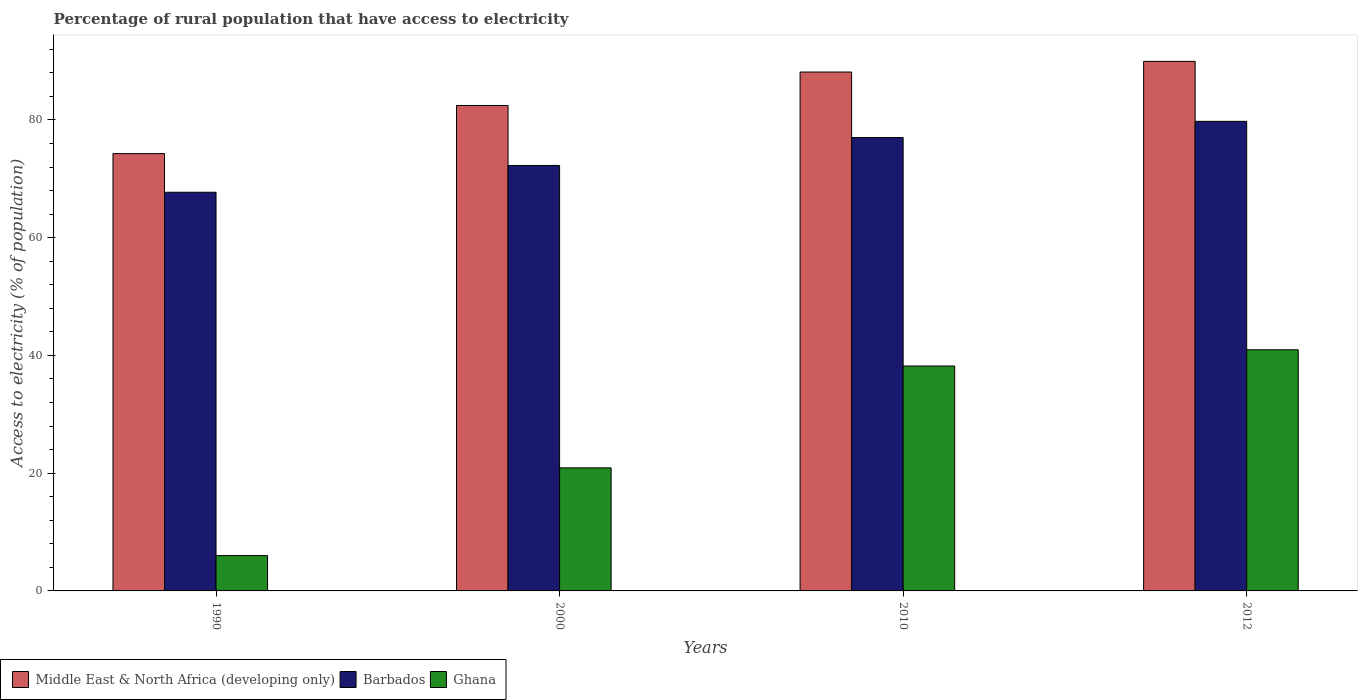How many different coloured bars are there?
Offer a terse response. 3. How many groups of bars are there?
Your answer should be very brief. 4. Are the number of bars per tick equal to the number of legend labels?
Give a very brief answer. Yes. How many bars are there on the 4th tick from the left?
Offer a terse response. 3. What is the label of the 1st group of bars from the left?
Keep it short and to the point. 1990. In how many cases, is the number of bars for a given year not equal to the number of legend labels?
Ensure brevity in your answer.  0. What is the percentage of rural population that have access to electricity in Ghana in 2012?
Your answer should be very brief. 40.95. Across all years, what is the maximum percentage of rural population that have access to electricity in Barbados?
Provide a succinct answer. 79.75. In which year was the percentage of rural population that have access to electricity in Ghana maximum?
Your answer should be very brief. 2012. In which year was the percentage of rural population that have access to electricity in Barbados minimum?
Make the answer very short. 1990. What is the total percentage of rural population that have access to electricity in Ghana in the graph?
Give a very brief answer. 106.05. What is the difference between the percentage of rural population that have access to electricity in Middle East & North Africa (developing only) in 1990 and that in 2000?
Your response must be concise. -8.17. What is the difference between the percentage of rural population that have access to electricity in Middle East & North Africa (developing only) in 2010 and the percentage of rural population that have access to electricity in Barbados in 1990?
Provide a succinct answer. 20.42. What is the average percentage of rural population that have access to electricity in Middle East & North Africa (developing only) per year?
Make the answer very short. 83.7. In the year 1990, what is the difference between the percentage of rural population that have access to electricity in Middle East & North Africa (developing only) and percentage of rural population that have access to electricity in Barbados?
Give a very brief answer. 6.57. In how many years, is the percentage of rural population that have access to electricity in Barbados greater than 64 %?
Ensure brevity in your answer.  4. What is the ratio of the percentage of rural population that have access to electricity in Ghana in 1990 to that in 2012?
Your answer should be very brief. 0.15. Is the percentage of rural population that have access to electricity in Ghana in 2000 less than that in 2012?
Offer a terse response. Yes. Is the difference between the percentage of rural population that have access to electricity in Middle East & North Africa (developing only) in 2000 and 2012 greater than the difference between the percentage of rural population that have access to electricity in Barbados in 2000 and 2012?
Provide a succinct answer. No. What is the difference between the highest and the second highest percentage of rural population that have access to electricity in Ghana?
Your answer should be very brief. 2.75. What is the difference between the highest and the lowest percentage of rural population that have access to electricity in Ghana?
Your response must be concise. 34.95. In how many years, is the percentage of rural population that have access to electricity in Ghana greater than the average percentage of rural population that have access to electricity in Ghana taken over all years?
Offer a very short reply. 2. What does the 3rd bar from the left in 1990 represents?
Your answer should be compact. Ghana. What does the 1st bar from the right in 2000 represents?
Provide a short and direct response. Ghana. How many bars are there?
Give a very brief answer. 12. Are the values on the major ticks of Y-axis written in scientific E-notation?
Your answer should be very brief. No. How are the legend labels stacked?
Your answer should be very brief. Horizontal. What is the title of the graph?
Your answer should be compact. Percentage of rural population that have access to electricity. What is the label or title of the X-axis?
Provide a short and direct response. Years. What is the label or title of the Y-axis?
Your answer should be very brief. Access to electricity (% of population). What is the Access to electricity (% of population) of Middle East & North Africa (developing only) in 1990?
Ensure brevity in your answer.  74.28. What is the Access to electricity (% of population) in Barbados in 1990?
Offer a very short reply. 67.71. What is the Access to electricity (% of population) in Ghana in 1990?
Your answer should be very brief. 6. What is the Access to electricity (% of population) in Middle East & North Africa (developing only) in 2000?
Ensure brevity in your answer.  82.45. What is the Access to electricity (% of population) in Barbados in 2000?
Your answer should be compact. 72.27. What is the Access to electricity (% of population) of Ghana in 2000?
Offer a very short reply. 20.9. What is the Access to electricity (% of population) in Middle East & North Africa (developing only) in 2010?
Your answer should be compact. 88.13. What is the Access to electricity (% of population) in Ghana in 2010?
Provide a succinct answer. 38.2. What is the Access to electricity (% of population) in Middle East & North Africa (developing only) in 2012?
Ensure brevity in your answer.  89.94. What is the Access to electricity (% of population) in Barbados in 2012?
Give a very brief answer. 79.75. What is the Access to electricity (% of population) of Ghana in 2012?
Ensure brevity in your answer.  40.95. Across all years, what is the maximum Access to electricity (% of population) in Middle East & North Africa (developing only)?
Make the answer very short. 89.94. Across all years, what is the maximum Access to electricity (% of population) in Barbados?
Make the answer very short. 79.75. Across all years, what is the maximum Access to electricity (% of population) in Ghana?
Offer a very short reply. 40.95. Across all years, what is the minimum Access to electricity (% of population) of Middle East & North Africa (developing only)?
Your response must be concise. 74.28. Across all years, what is the minimum Access to electricity (% of population) of Barbados?
Keep it short and to the point. 67.71. What is the total Access to electricity (% of population) of Middle East & North Africa (developing only) in the graph?
Keep it short and to the point. 334.8. What is the total Access to electricity (% of population) of Barbados in the graph?
Provide a succinct answer. 296.73. What is the total Access to electricity (% of population) of Ghana in the graph?
Your response must be concise. 106.05. What is the difference between the Access to electricity (% of population) in Middle East & North Africa (developing only) in 1990 and that in 2000?
Offer a very short reply. -8.17. What is the difference between the Access to electricity (% of population) in Barbados in 1990 and that in 2000?
Keep it short and to the point. -4.55. What is the difference between the Access to electricity (% of population) in Ghana in 1990 and that in 2000?
Your answer should be compact. -14.9. What is the difference between the Access to electricity (% of population) in Middle East & North Africa (developing only) in 1990 and that in 2010?
Provide a succinct answer. -13.86. What is the difference between the Access to electricity (% of population) in Barbados in 1990 and that in 2010?
Provide a short and direct response. -9.29. What is the difference between the Access to electricity (% of population) of Ghana in 1990 and that in 2010?
Your response must be concise. -32.2. What is the difference between the Access to electricity (% of population) of Middle East & North Africa (developing only) in 1990 and that in 2012?
Give a very brief answer. -15.67. What is the difference between the Access to electricity (% of population) in Barbados in 1990 and that in 2012?
Your answer should be compact. -12.04. What is the difference between the Access to electricity (% of population) in Ghana in 1990 and that in 2012?
Keep it short and to the point. -34.95. What is the difference between the Access to electricity (% of population) in Middle East & North Africa (developing only) in 2000 and that in 2010?
Give a very brief answer. -5.68. What is the difference between the Access to electricity (% of population) of Barbados in 2000 and that in 2010?
Give a very brief answer. -4.74. What is the difference between the Access to electricity (% of population) of Ghana in 2000 and that in 2010?
Provide a succinct answer. -17.3. What is the difference between the Access to electricity (% of population) in Middle East & North Africa (developing only) in 2000 and that in 2012?
Make the answer very short. -7.5. What is the difference between the Access to electricity (% of population) of Barbados in 2000 and that in 2012?
Give a very brief answer. -7.49. What is the difference between the Access to electricity (% of population) in Ghana in 2000 and that in 2012?
Offer a terse response. -20.05. What is the difference between the Access to electricity (% of population) in Middle East & North Africa (developing only) in 2010 and that in 2012?
Provide a short and direct response. -1.81. What is the difference between the Access to electricity (% of population) of Barbados in 2010 and that in 2012?
Provide a succinct answer. -2.75. What is the difference between the Access to electricity (% of population) in Ghana in 2010 and that in 2012?
Make the answer very short. -2.75. What is the difference between the Access to electricity (% of population) in Middle East & North Africa (developing only) in 1990 and the Access to electricity (% of population) in Barbados in 2000?
Give a very brief answer. 2.01. What is the difference between the Access to electricity (% of population) in Middle East & North Africa (developing only) in 1990 and the Access to electricity (% of population) in Ghana in 2000?
Offer a very short reply. 53.38. What is the difference between the Access to electricity (% of population) of Barbados in 1990 and the Access to electricity (% of population) of Ghana in 2000?
Provide a succinct answer. 46.81. What is the difference between the Access to electricity (% of population) of Middle East & North Africa (developing only) in 1990 and the Access to electricity (% of population) of Barbados in 2010?
Your answer should be compact. -2.72. What is the difference between the Access to electricity (% of population) of Middle East & North Africa (developing only) in 1990 and the Access to electricity (% of population) of Ghana in 2010?
Make the answer very short. 36.08. What is the difference between the Access to electricity (% of population) in Barbados in 1990 and the Access to electricity (% of population) in Ghana in 2010?
Keep it short and to the point. 29.51. What is the difference between the Access to electricity (% of population) of Middle East & North Africa (developing only) in 1990 and the Access to electricity (% of population) of Barbados in 2012?
Your response must be concise. -5.48. What is the difference between the Access to electricity (% of population) in Middle East & North Africa (developing only) in 1990 and the Access to electricity (% of population) in Ghana in 2012?
Your answer should be compact. 33.32. What is the difference between the Access to electricity (% of population) in Barbados in 1990 and the Access to electricity (% of population) in Ghana in 2012?
Your answer should be very brief. 26.76. What is the difference between the Access to electricity (% of population) in Middle East & North Africa (developing only) in 2000 and the Access to electricity (% of population) in Barbados in 2010?
Make the answer very short. 5.45. What is the difference between the Access to electricity (% of population) of Middle East & North Africa (developing only) in 2000 and the Access to electricity (% of population) of Ghana in 2010?
Make the answer very short. 44.25. What is the difference between the Access to electricity (% of population) of Barbados in 2000 and the Access to electricity (% of population) of Ghana in 2010?
Make the answer very short. 34.06. What is the difference between the Access to electricity (% of population) in Middle East & North Africa (developing only) in 2000 and the Access to electricity (% of population) in Barbados in 2012?
Provide a succinct answer. 2.69. What is the difference between the Access to electricity (% of population) of Middle East & North Africa (developing only) in 2000 and the Access to electricity (% of population) of Ghana in 2012?
Provide a succinct answer. 41.49. What is the difference between the Access to electricity (% of population) in Barbados in 2000 and the Access to electricity (% of population) in Ghana in 2012?
Your answer should be very brief. 31.31. What is the difference between the Access to electricity (% of population) of Middle East & North Africa (developing only) in 2010 and the Access to electricity (% of population) of Barbados in 2012?
Your response must be concise. 8.38. What is the difference between the Access to electricity (% of population) of Middle East & North Africa (developing only) in 2010 and the Access to electricity (% of population) of Ghana in 2012?
Keep it short and to the point. 47.18. What is the difference between the Access to electricity (% of population) of Barbados in 2010 and the Access to electricity (% of population) of Ghana in 2012?
Make the answer very short. 36.05. What is the average Access to electricity (% of population) in Middle East & North Africa (developing only) per year?
Offer a terse response. 83.7. What is the average Access to electricity (% of population) in Barbados per year?
Ensure brevity in your answer.  74.18. What is the average Access to electricity (% of population) of Ghana per year?
Provide a short and direct response. 26.51. In the year 1990, what is the difference between the Access to electricity (% of population) of Middle East & North Africa (developing only) and Access to electricity (% of population) of Barbados?
Offer a very short reply. 6.57. In the year 1990, what is the difference between the Access to electricity (% of population) of Middle East & North Africa (developing only) and Access to electricity (% of population) of Ghana?
Provide a succinct answer. 68.28. In the year 1990, what is the difference between the Access to electricity (% of population) of Barbados and Access to electricity (% of population) of Ghana?
Keep it short and to the point. 61.71. In the year 2000, what is the difference between the Access to electricity (% of population) of Middle East & North Africa (developing only) and Access to electricity (% of population) of Barbados?
Keep it short and to the point. 10.18. In the year 2000, what is the difference between the Access to electricity (% of population) of Middle East & North Africa (developing only) and Access to electricity (% of population) of Ghana?
Ensure brevity in your answer.  61.55. In the year 2000, what is the difference between the Access to electricity (% of population) of Barbados and Access to electricity (% of population) of Ghana?
Provide a succinct answer. 51.37. In the year 2010, what is the difference between the Access to electricity (% of population) in Middle East & North Africa (developing only) and Access to electricity (% of population) in Barbados?
Offer a terse response. 11.13. In the year 2010, what is the difference between the Access to electricity (% of population) in Middle East & North Africa (developing only) and Access to electricity (% of population) in Ghana?
Make the answer very short. 49.93. In the year 2010, what is the difference between the Access to electricity (% of population) of Barbados and Access to electricity (% of population) of Ghana?
Make the answer very short. 38.8. In the year 2012, what is the difference between the Access to electricity (% of population) in Middle East & North Africa (developing only) and Access to electricity (% of population) in Barbados?
Provide a succinct answer. 10.19. In the year 2012, what is the difference between the Access to electricity (% of population) of Middle East & North Africa (developing only) and Access to electricity (% of population) of Ghana?
Provide a short and direct response. 48.99. In the year 2012, what is the difference between the Access to electricity (% of population) of Barbados and Access to electricity (% of population) of Ghana?
Your response must be concise. 38.8. What is the ratio of the Access to electricity (% of population) in Middle East & North Africa (developing only) in 1990 to that in 2000?
Give a very brief answer. 0.9. What is the ratio of the Access to electricity (% of population) of Barbados in 1990 to that in 2000?
Ensure brevity in your answer.  0.94. What is the ratio of the Access to electricity (% of population) in Ghana in 1990 to that in 2000?
Give a very brief answer. 0.29. What is the ratio of the Access to electricity (% of population) in Middle East & North Africa (developing only) in 1990 to that in 2010?
Your answer should be compact. 0.84. What is the ratio of the Access to electricity (% of population) of Barbados in 1990 to that in 2010?
Ensure brevity in your answer.  0.88. What is the ratio of the Access to electricity (% of population) in Ghana in 1990 to that in 2010?
Your answer should be compact. 0.16. What is the ratio of the Access to electricity (% of population) in Middle East & North Africa (developing only) in 1990 to that in 2012?
Ensure brevity in your answer.  0.83. What is the ratio of the Access to electricity (% of population) in Barbados in 1990 to that in 2012?
Keep it short and to the point. 0.85. What is the ratio of the Access to electricity (% of population) of Ghana in 1990 to that in 2012?
Ensure brevity in your answer.  0.15. What is the ratio of the Access to electricity (% of population) in Middle East & North Africa (developing only) in 2000 to that in 2010?
Make the answer very short. 0.94. What is the ratio of the Access to electricity (% of population) of Barbados in 2000 to that in 2010?
Offer a very short reply. 0.94. What is the ratio of the Access to electricity (% of population) in Ghana in 2000 to that in 2010?
Give a very brief answer. 0.55. What is the ratio of the Access to electricity (% of population) in Barbados in 2000 to that in 2012?
Give a very brief answer. 0.91. What is the ratio of the Access to electricity (% of population) of Ghana in 2000 to that in 2012?
Keep it short and to the point. 0.51. What is the ratio of the Access to electricity (% of population) in Middle East & North Africa (developing only) in 2010 to that in 2012?
Provide a short and direct response. 0.98. What is the ratio of the Access to electricity (% of population) in Barbados in 2010 to that in 2012?
Offer a terse response. 0.97. What is the ratio of the Access to electricity (% of population) of Ghana in 2010 to that in 2012?
Keep it short and to the point. 0.93. What is the difference between the highest and the second highest Access to electricity (% of population) in Middle East & North Africa (developing only)?
Your response must be concise. 1.81. What is the difference between the highest and the second highest Access to electricity (% of population) of Barbados?
Keep it short and to the point. 2.75. What is the difference between the highest and the second highest Access to electricity (% of population) in Ghana?
Ensure brevity in your answer.  2.75. What is the difference between the highest and the lowest Access to electricity (% of population) in Middle East & North Africa (developing only)?
Provide a succinct answer. 15.67. What is the difference between the highest and the lowest Access to electricity (% of population) of Barbados?
Keep it short and to the point. 12.04. What is the difference between the highest and the lowest Access to electricity (% of population) in Ghana?
Provide a succinct answer. 34.95. 